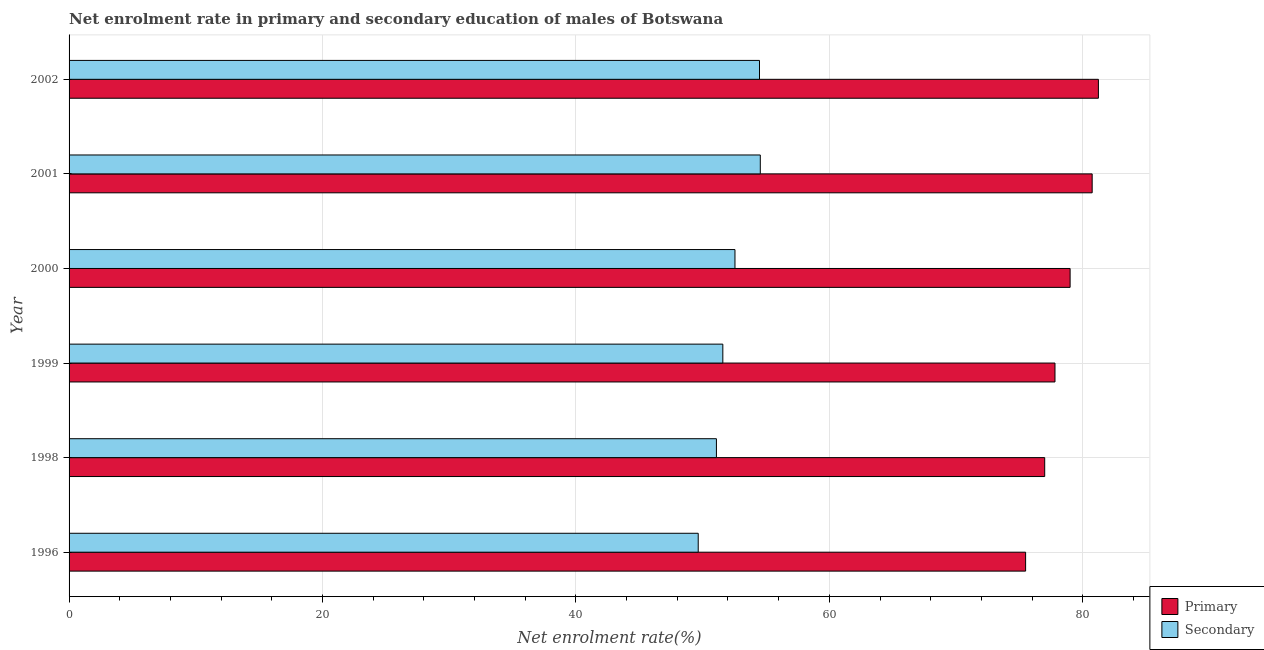How many different coloured bars are there?
Offer a very short reply. 2. Are the number of bars per tick equal to the number of legend labels?
Give a very brief answer. Yes. Are the number of bars on each tick of the Y-axis equal?
Your answer should be compact. Yes. How many bars are there on the 5th tick from the bottom?
Offer a very short reply. 2. What is the label of the 6th group of bars from the top?
Offer a very short reply. 1996. What is the enrollment rate in primary education in 1996?
Your answer should be compact. 75.49. Across all years, what is the maximum enrollment rate in primary education?
Provide a short and direct response. 81.23. Across all years, what is the minimum enrollment rate in secondary education?
Make the answer very short. 49.65. In which year was the enrollment rate in primary education maximum?
Keep it short and to the point. 2002. In which year was the enrollment rate in secondary education minimum?
Make the answer very short. 1996. What is the total enrollment rate in primary education in the graph?
Give a very brief answer. 471.26. What is the difference between the enrollment rate in secondary education in 1996 and that in 2001?
Ensure brevity in your answer.  -4.9. What is the difference between the enrollment rate in secondary education in 2000 and the enrollment rate in primary education in 2002?
Keep it short and to the point. -28.68. What is the average enrollment rate in primary education per year?
Make the answer very short. 78.54. In the year 2002, what is the difference between the enrollment rate in primary education and enrollment rate in secondary education?
Ensure brevity in your answer.  26.75. Is the enrollment rate in primary education in 1996 less than that in 2000?
Your response must be concise. Yes. What is the difference between the highest and the second highest enrollment rate in primary education?
Your answer should be very brief. 0.49. What is the difference between the highest and the lowest enrollment rate in primary education?
Make the answer very short. 5.74. Is the sum of the enrollment rate in primary education in 1996 and 1999 greater than the maximum enrollment rate in secondary education across all years?
Offer a very short reply. Yes. What does the 2nd bar from the top in 2001 represents?
Your response must be concise. Primary. What does the 1st bar from the bottom in 1996 represents?
Your response must be concise. Primary. How many years are there in the graph?
Offer a very short reply. 6. Does the graph contain any zero values?
Provide a short and direct response. No. How many legend labels are there?
Your answer should be compact. 2. How are the legend labels stacked?
Give a very brief answer. Vertical. What is the title of the graph?
Offer a very short reply. Net enrolment rate in primary and secondary education of males of Botswana. Does "Transport services" appear as one of the legend labels in the graph?
Ensure brevity in your answer.  No. What is the label or title of the X-axis?
Keep it short and to the point. Net enrolment rate(%). What is the label or title of the Y-axis?
Your answer should be compact. Year. What is the Net enrolment rate(%) of Primary in 1996?
Keep it short and to the point. 75.49. What is the Net enrolment rate(%) in Secondary in 1996?
Your answer should be compact. 49.65. What is the Net enrolment rate(%) in Primary in 1998?
Keep it short and to the point. 76.99. What is the Net enrolment rate(%) in Secondary in 1998?
Your answer should be very brief. 51.09. What is the Net enrolment rate(%) of Primary in 1999?
Make the answer very short. 77.81. What is the Net enrolment rate(%) in Secondary in 1999?
Provide a short and direct response. 51.59. What is the Net enrolment rate(%) of Primary in 2000?
Keep it short and to the point. 79. What is the Net enrolment rate(%) in Secondary in 2000?
Your response must be concise. 52.55. What is the Net enrolment rate(%) in Primary in 2001?
Ensure brevity in your answer.  80.74. What is the Net enrolment rate(%) in Secondary in 2001?
Ensure brevity in your answer.  54.55. What is the Net enrolment rate(%) of Primary in 2002?
Ensure brevity in your answer.  81.23. What is the Net enrolment rate(%) in Secondary in 2002?
Keep it short and to the point. 54.49. Across all years, what is the maximum Net enrolment rate(%) in Primary?
Provide a short and direct response. 81.23. Across all years, what is the maximum Net enrolment rate(%) in Secondary?
Your response must be concise. 54.55. Across all years, what is the minimum Net enrolment rate(%) in Primary?
Your answer should be very brief. 75.49. Across all years, what is the minimum Net enrolment rate(%) of Secondary?
Your answer should be very brief. 49.65. What is the total Net enrolment rate(%) of Primary in the graph?
Offer a terse response. 471.26. What is the total Net enrolment rate(%) in Secondary in the graph?
Keep it short and to the point. 313.92. What is the difference between the Net enrolment rate(%) in Primary in 1996 and that in 1998?
Keep it short and to the point. -1.51. What is the difference between the Net enrolment rate(%) of Secondary in 1996 and that in 1998?
Your answer should be compact. -1.44. What is the difference between the Net enrolment rate(%) of Primary in 1996 and that in 1999?
Your response must be concise. -2.32. What is the difference between the Net enrolment rate(%) of Secondary in 1996 and that in 1999?
Your answer should be very brief. -1.94. What is the difference between the Net enrolment rate(%) in Primary in 1996 and that in 2000?
Your answer should be compact. -3.51. What is the difference between the Net enrolment rate(%) of Secondary in 1996 and that in 2000?
Make the answer very short. -2.9. What is the difference between the Net enrolment rate(%) of Primary in 1996 and that in 2001?
Ensure brevity in your answer.  -5.25. What is the difference between the Net enrolment rate(%) of Secondary in 1996 and that in 2001?
Provide a short and direct response. -4.9. What is the difference between the Net enrolment rate(%) in Primary in 1996 and that in 2002?
Make the answer very short. -5.74. What is the difference between the Net enrolment rate(%) of Secondary in 1996 and that in 2002?
Your answer should be compact. -4.84. What is the difference between the Net enrolment rate(%) in Primary in 1998 and that in 1999?
Your answer should be very brief. -0.81. What is the difference between the Net enrolment rate(%) of Secondary in 1998 and that in 1999?
Your response must be concise. -0.51. What is the difference between the Net enrolment rate(%) in Primary in 1998 and that in 2000?
Offer a terse response. -2.01. What is the difference between the Net enrolment rate(%) in Secondary in 1998 and that in 2000?
Your response must be concise. -1.46. What is the difference between the Net enrolment rate(%) of Primary in 1998 and that in 2001?
Make the answer very short. -3.75. What is the difference between the Net enrolment rate(%) of Secondary in 1998 and that in 2001?
Ensure brevity in your answer.  -3.46. What is the difference between the Net enrolment rate(%) of Primary in 1998 and that in 2002?
Your answer should be very brief. -4.24. What is the difference between the Net enrolment rate(%) of Secondary in 1998 and that in 2002?
Your answer should be compact. -3.4. What is the difference between the Net enrolment rate(%) of Primary in 1999 and that in 2000?
Keep it short and to the point. -1.19. What is the difference between the Net enrolment rate(%) in Secondary in 1999 and that in 2000?
Keep it short and to the point. -0.96. What is the difference between the Net enrolment rate(%) in Primary in 1999 and that in 2001?
Give a very brief answer. -2.93. What is the difference between the Net enrolment rate(%) in Secondary in 1999 and that in 2001?
Keep it short and to the point. -2.96. What is the difference between the Net enrolment rate(%) of Primary in 1999 and that in 2002?
Provide a succinct answer. -3.43. What is the difference between the Net enrolment rate(%) in Secondary in 1999 and that in 2002?
Your answer should be compact. -2.89. What is the difference between the Net enrolment rate(%) of Primary in 2000 and that in 2001?
Your response must be concise. -1.74. What is the difference between the Net enrolment rate(%) of Secondary in 2000 and that in 2001?
Your response must be concise. -2. What is the difference between the Net enrolment rate(%) of Primary in 2000 and that in 2002?
Offer a terse response. -2.23. What is the difference between the Net enrolment rate(%) in Secondary in 2000 and that in 2002?
Keep it short and to the point. -1.94. What is the difference between the Net enrolment rate(%) of Primary in 2001 and that in 2002?
Your answer should be very brief. -0.49. What is the difference between the Net enrolment rate(%) of Secondary in 2001 and that in 2002?
Ensure brevity in your answer.  0.06. What is the difference between the Net enrolment rate(%) in Primary in 1996 and the Net enrolment rate(%) in Secondary in 1998?
Your response must be concise. 24.4. What is the difference between the Net enrolment rate(%) of Primary in 1996 and the Net enrolment rate(%) of Secondary in 1999?
Your response must be concise. 23.9. What is the difference between the Net enrolment rate(%) of Primary in 1996 and the Net enrolment rate(%) of Secondary in 2000?
Ensure brevity in your answer.  22.94. What is the difference between the Net enrolment rate(%) of Primary in 1996 and the Net enrolment rate(%) of Secondary in 2001?
Ensure brevity in your answer.  20.94. What is the difference between the Net enrolment rate(%) of Primary in 1996 and the Net enrolment rate(%) of Secondary in 2002?
Offer a terse response. 21. What is the difference between the Net enrolment rate(%) in Primary in 1998 and the Net enrolment rate(%) in Secondary in 1999?
Your answer should be compact. 25.4. What is the difference between the Net enrolment rate(%) of Primary in 1998 and the Net enrolment rate(%) of Secondary in 2000?
Ensure brevity in your answer.  24.44. What is the difference between the Net enrolment rate(%) in Primary in 1998 and the Net enrolment rate(%) in Secondary in 2001?
Make the answer very short. 22.44. What is the difference between the Net enrolment rate(%) in Primary in 1998 and the Net enrolment rate(%) in Secondary in 2002?
Provide a succinct answer. 22.51. What is the difference between the Net enrolment rate(%) of Primary in 1999 and the Net enrolment rate(%) of Secondary in 2000?
Your response must be concise. 25.26. What is the difference between the Net enrolment rate(%) in Primary in 1999 and the Net enrolment rate(%) in Secondary in 2001?
Provide a short and direct response. 23.26. What is the difference between the Net enrolment rate(%) in Primary in 1999 and the Net enrolment rate(%) in Secondary in 2002?
Offer a very short reply. 23.32. What is the difference between the Net enrolment rate(%) in Primary in 2000 and the Net enrolment rate(%) in Secondary in 2001?
Make the answer very short. 24.45. What is the difference between the Net enrolment rate(%) of Primary in 2000 and the Net enrolment rate(%) of Secondary in 2002?
Offer a very short reply. 24.51. What is the difference between the Net enrolment rate(%) in Primary in 2001 and the Net enrolment rate(%) in Secondary in 2002?
Give a very brief answer. 26.25. What is the average Net enrolment rate(%) in Primary per year?
Make the answer very short. 78.54. What is the average Net enrolment rate(%) in Secondary per year?
Ensure brevity in your answer.  52.32. In the year 1996, what is the difference between the Net enrolment rate(%) of Primary and Net enrolment rate(%) of Secondary?
Provide a succinct answer. 25.84. In the year 1998, what is the difference between the Net enrolment rate(%) in Primary and Net enrolment rate(%) in Secondary?
Give a very brief answer. 25.91. In the year 1999, what is the difference between the Net enrolment rate(%) in Primary and Net enrolment rate(%) in Secondary?
Provide a succinct answer. 26.21. In the year 2000, what is the difference between the Net enrolment rate(%) of Primary and Net enrolment rate(%) of Secondary?
Offer a terse response. 26.45. In the year 2001, what is the difference between the Net enrolment rate(%) in Primary and Net enrolment rate(%) in Secondary?
Your response must be concise. 26.19. In the year 2002, what is the difference between the Net enrolment rate(%) of Primary and Net enrolment rate(%) of Secondary?
Give a very brief answer. 26.75. What is the ratio of the Net enrolment rate(%) in Primary in 1996 to that in 1998?
Make the answer very short. 0.98. What is the ratio of the Net enrolment rate(%) in Secondary in 1996 to that in 1998?
Make the answer very short. 0.97. What is the ratio of the Net enrolment rate(%) of Primary in 1996 to that in 1999?
Your answer should be compact. 0.97. What is the ratio of the Net enrolment rate(%) of Secondary in 1996 to that in 1999?
Offer a very short reply. 0.96. What is the ratio of the Net enrolment rate(%) in Primary in 1996 to that in 2000?
Your answer should be very brief. 0.96. What is the ratio of the Net enrolment rate(%) in Secondary in 1996 to that in 2000?
Make the answer very short. 0.94. What is the ratio of the Net enrolment rate(%) in Primary in 1996 to that in 2001?
Give a very brief answer. 0.93. What is the ratio of the Net enrolment rate(%) in Secondary in 1996 to that in 2001?
Provide a short and direct response. 0.91. What is the ratio of the Net enrolment rate(%) in Primary in 1996 to that in 2002?
Your answer should be compact. 0.93. What is the ratio of the Net enrolment rate(%) in Secondary in 1996 to that in 2002?
Offer a very short reply. 0.91. What is the ratio of the Net enrolment rate(%) in Primary in 1998 to that in 1999?
Your response must be concise. 0.99. What is the ratio of the Net enrolment rate(%) of Secondary in 1998 to that in 1999?
Make the answer very short. 0.99. What is the ratio of the Net enrolment rate(%) of Primary in 1998 to that in 2000?
Your answer should be compact. 0.97. What is the ratio of the Net enrolment rate(%) of Secondary in 1998 to that in 2000?
Offer a very short reply. 0.97. What is the ratio of the Net enrolment rate(%) in Primary in 1998 to that in 2001?
Keep it short and to the point. 0.95. What is the ratio of the Net enrolment rate(%) in Secondary in 1998 to that in 2001?
Ensure brevity in your answer.  0.94. What is the ratio of the Net enrolment rate(%) of Primary in 1998 to that in 2002?
Your answer should be very brief. 0.95. What is the ratio of the Net enrolment rate(%) in Secondary in 1998 to that in 2002?
Your response must be concise. 0.94. What is the ratio of the Net enrolment rate(%) of Primary in 1999 to that in 2000?
Your answer should be very brief. 0.98. What is the ratio of the Net enrolment rate(%) in Secondary in 1999 to that in 2000?
Your answer should be compact. 0.98. What is the ratio of the Net enrolment rate(%) in Primary in 1999 to that in 2001?
Keep it short and to the point. 0.96. What is the ratio of the Net enrolment rate(%) in Secondary in 1999 to that in 2001?
Keep it short and to the point. 0.95. What is the ratio of the Net enrolment rate(%) in Primary in 1999 to that in 2002?
Provide a short and direct response. 0.96. What is the ratio of the Net enrolment rate(%) of Secondary in 1999 to that in 2002?
Your answer should be very brief. 0.95. What is the ratio of the Net enrolment rate(%) of Primary in 2000 to that in 2001?
Give a very brief answer. 0.98. What is the ratio of the Net enrolment rate(%) of Secondary in 2000 to that in 2001?
Offer a terse response. 0.96. What is the ratio of the Net enrolment rate(%) in Primary in 2000 to that in 2002?
Offer a very short reply. 0.97. What is the ratio of the Net enrolment rate(%) of Secondary in 2000 to that in 2002?
Your answer should be compact. 0.96. What is the ratio of the Net enrolment rate(%) in Secondary in 2001 to that in 2002?
Offer a terse response. 1. What is the difference between the highest and the second highest Net enrolment rate(%) of Primary?
Your response must be concise. 0.49. What is the difference between the highest and the second highest Net enrolment rate(%) of Secondary?
Make the answer very short. 0.06. What is the difference between the highest and the lowest Net enrolment rate(%) of Primary?
Your answer should be compact. 5.74. What is the difference between the highest and the lowest Net enrolment rate(%) of Secondary?
Provide a short and direct response. 4.9. 